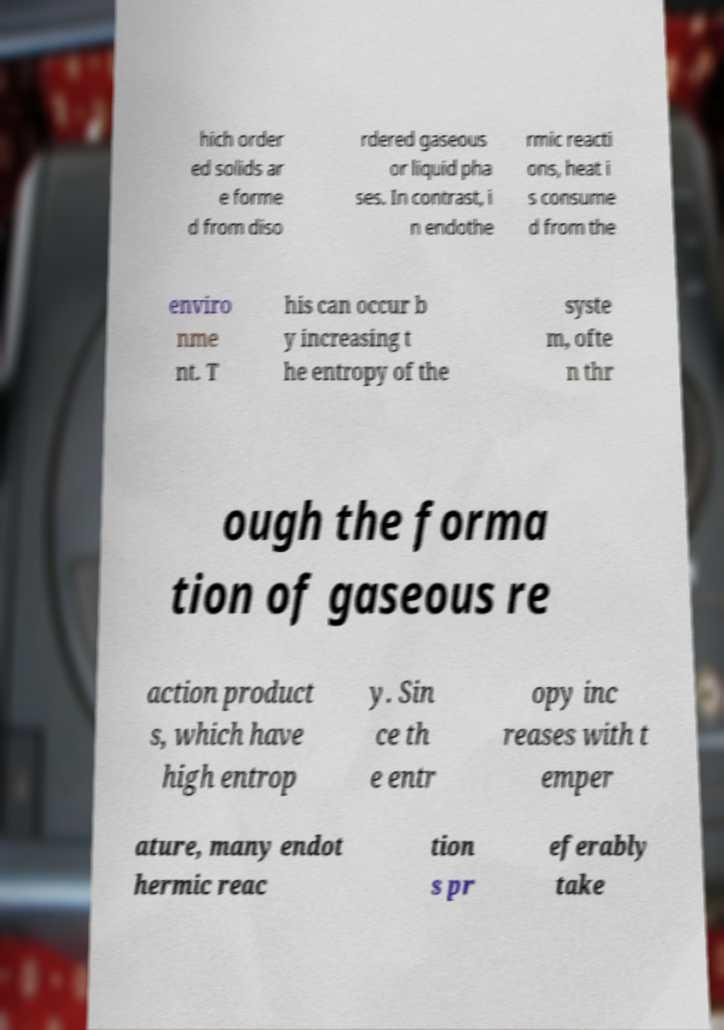For documentation purposes, I need the text within this image transcribed. Could you provide that? hich order ed solids ar e forme d from diso rdered gaseous or liquid pha ses. In contrast, i n endothe rmic reacti ons, heat i s consume d from the enviro nme nt. T his can occur b y increasing t he entropy of the syste m, ofte n thr ough the forma tion of gaseous re action product s, which have high entrop y. Sin ce th e entr opy inc reases with t emper ature, many endot hermic reac tion s pr eferably take 